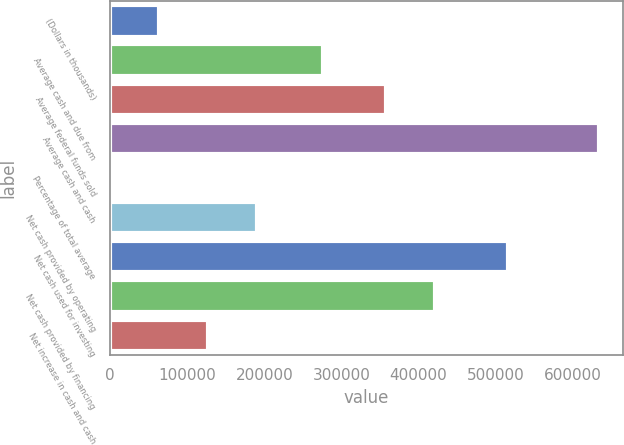Convert chart to OTSL. <chart><loc_0><loc_0><loc_500><loc_500><bar_chart><fcel>(Dollars in thousands)<fcel>Average cash and due from<fcel>Average federal funds sold<fcel>Average cash and cash<fcel>Percentage of total average<fcel>Net cash provided by operating<fcel>Net cash used for investing<fcel>Net cash provided by financing<fcel>Net increase in cash and cash<nl><fcel>63367.4<fcel>275907<fcel>357673<fcel>633580<fcel>10.5<fcel>190081<fcel>515506<fcel>421030<fcel>126724<nl></chart> 